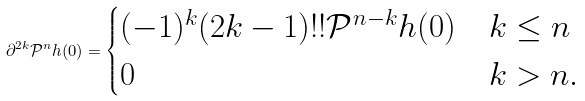Convert formula to latex. <formula><loc_0><loc_0><loc_500><loc_500>\partial ^ { 2 k } \mathcal { P } ^ { n } h ( 0 ) = \begin{cases} ( - 1 ) ^ { k } ( 2 k - 1 ) ! ! \mathcal { P } ^ { n - k } h ( 0 ) & k \leq n \\ 0 & k > n . \end{cases}</formula> 